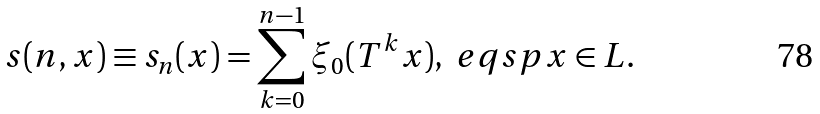Convert formula to latex. <formula><loc_0><loc_0><loc_500><loc_500>s ( n , x ) \equiv s _ { n } ( x ) = \sum _ { k = 0 } ^ { n - 1 } \xi _ { 0 } ( T ^ { k } x ) , \ e q s p x \in L .</formula> 